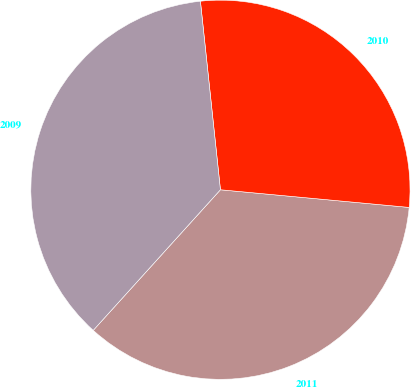<chart> <loc_0><loc_0><loc_500><loc_500><pie_chart><fcel>2011<fcel>2010<fcel>2009<nl><fcel>35.22%<fcel>28.17%<fcel>36.61%<nl></chart> 